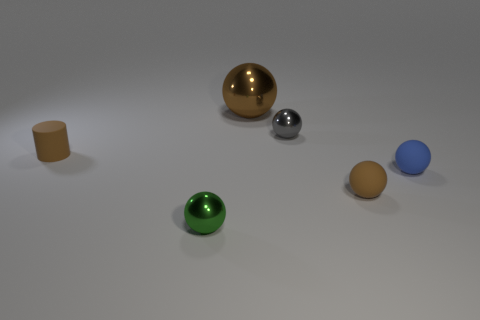How many objects are blue shiny blocks or small matte objects?
Provide a succinct answer. 3. There is a brown rubber sphere; does it have the same size as the shiny ball that is in front of the tiny brown cylinder?
Your response must be concise. Yes. There is a tiny shiny object behind the rubber object on the right side of the small brown thing that is to the right of the large thing; what is its color?
Provide a short and direct response. Gray. The big metallic object is what color?
Your answer should be compact. Brown. Are there more cylinders in front of the large sphere than large brown spheres in front of the tiny brown rubber cylinder?
Offer a very short reply. Yes. There is a small gray thing; is it the same shape as the metal object that is to the left of the large brown metal ball?
Your answer should be compact. Yes. There is a brown matte object that is in front of the tiny rubber cylinder; is it the same size as the brown sphere behind the gray ball?
Your answer should be very brief. No. Are there any blue objects that are on the right side of the object that is in front of the brown rubber object that is in front of the small brown matte cylinder?
Your response must be concise. Yes. Are there fewer tiny green things behind the tiny blue sphere than metallic objects that are behind the tiny rubber cylinder?
Offer a very short reply. Yes. There is a small brown thing that is made of the same material as the cylinder; what is its shape?
Provide a short and direct response. Sphere. 